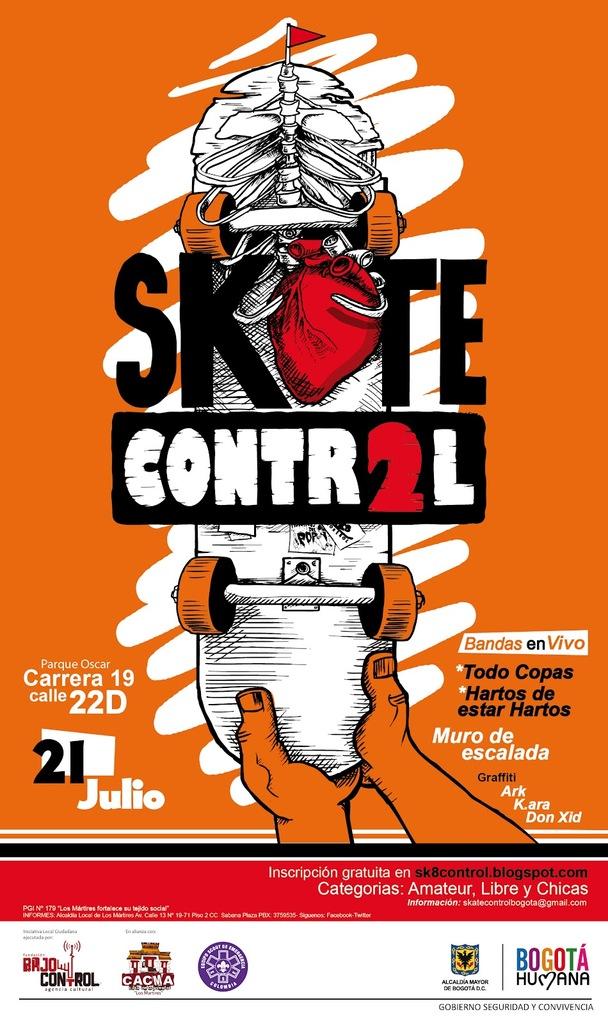What date is this event on?
Keep it short and to the point. 21 julio. 